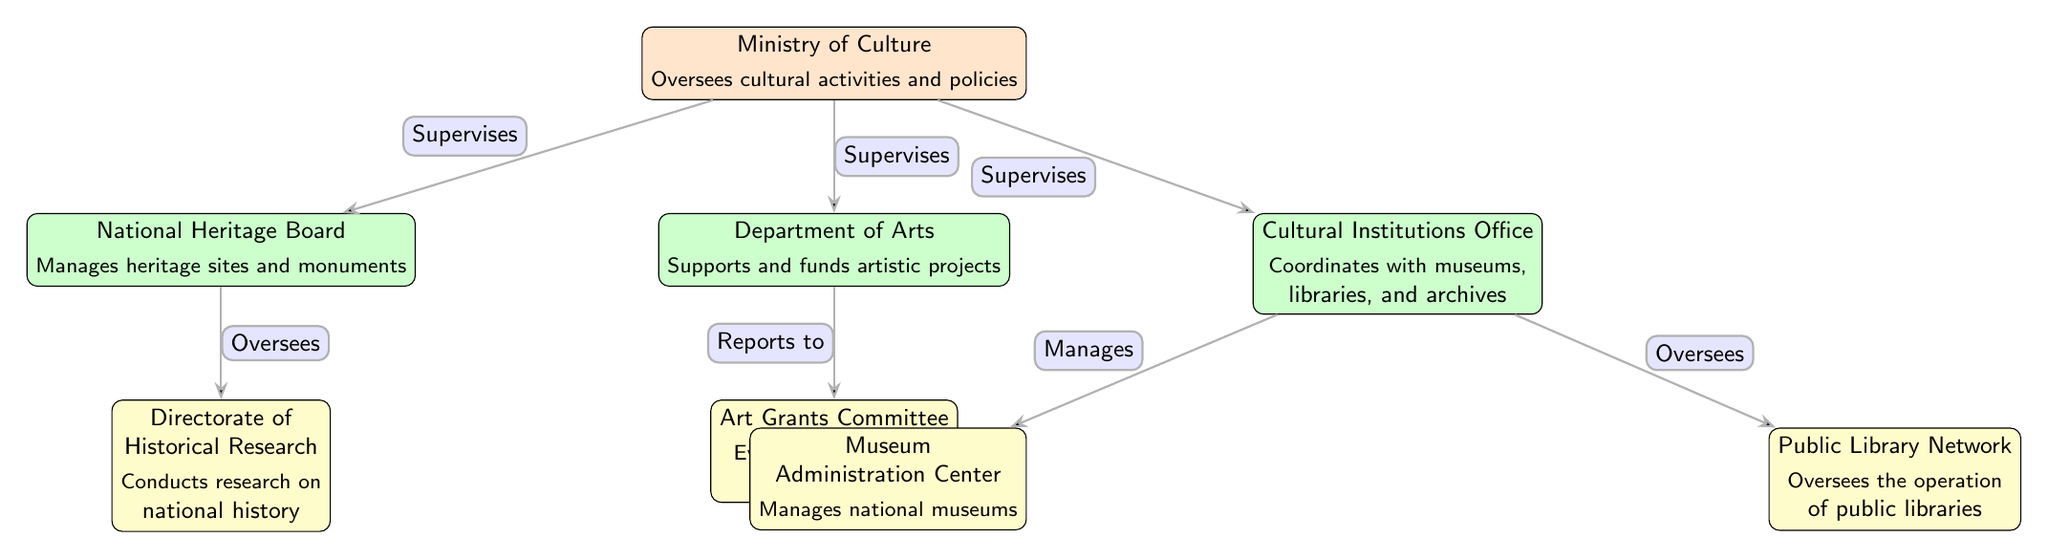What is the top node in the organizational chart? The top node in the organizational chart is the "Ministry of Culture". It is positioned at the highest level in the diagram, indicating that it oversees all the activities and ministries related to culture and heritage.
Answer: Ministry of Culture How many ministries are directly supervised by the Ministry of Culture? The Ministry of Culture directly supervises three ministries: the National Heritage Board, the Department of Arts, and the Cultural Institutions Office. This is shown by the lines connecting these nodes to the top node.
Answer: 3 Which office manages national museums? The office that manages national museums is the "Museum Administration Center". It is positioned below the Cultural Institutions Office, showing its responsibility for overseeing museums.
Answer: Museum Administration Center What type of projects does the Department of Arts support? The Department of Arts supports artistic projects. This is specified in the description of the node, indicating its focus on funding and supporting various artistic initiatives.
Answer: Artistic projects Which board oversees the evaluation of art grants? The board that oversees the evaluation of art grants is the "Art Grants Committee". This is indicated by the connection from the Department of Arts, which reports to this committee for funding purposes.
Answer: Art Grants Committee What entity conducts research on national history? The entity that conducts research on national history is the "Directorate of Historical Research". It is directly connected to the National Heritage Board, showing its role in researching heritage-related topics.
Answer: Directorate of Historical Research How does the Cultural Institutions Office interact with public libraries? The Cultural Institutions Office oversees the operation of public libraries, as indicated by the connecting line in the diagram. This reflects its responsibility in managing various cultural institutions, including libraries.
Answer: Oversees Which ministry is responsible for managing heritage sites and monuments? The ministry responsible for managing heritage sites and monuments is the "National Heritage Board". This is clarified in its description, detailing its role in heritage management.
Answer: National Heritage Board What is the relationship between the Department of Arts and the Art Grants Committee? The relationship between the Department of Arts and the Art Grants Committee is that the Department reports to the Art Grants Committee. This indicates a hierarchical reporting structure wherein the Department of Arts refers grant applications to the committee for evaluation.
Answer: Reports to 